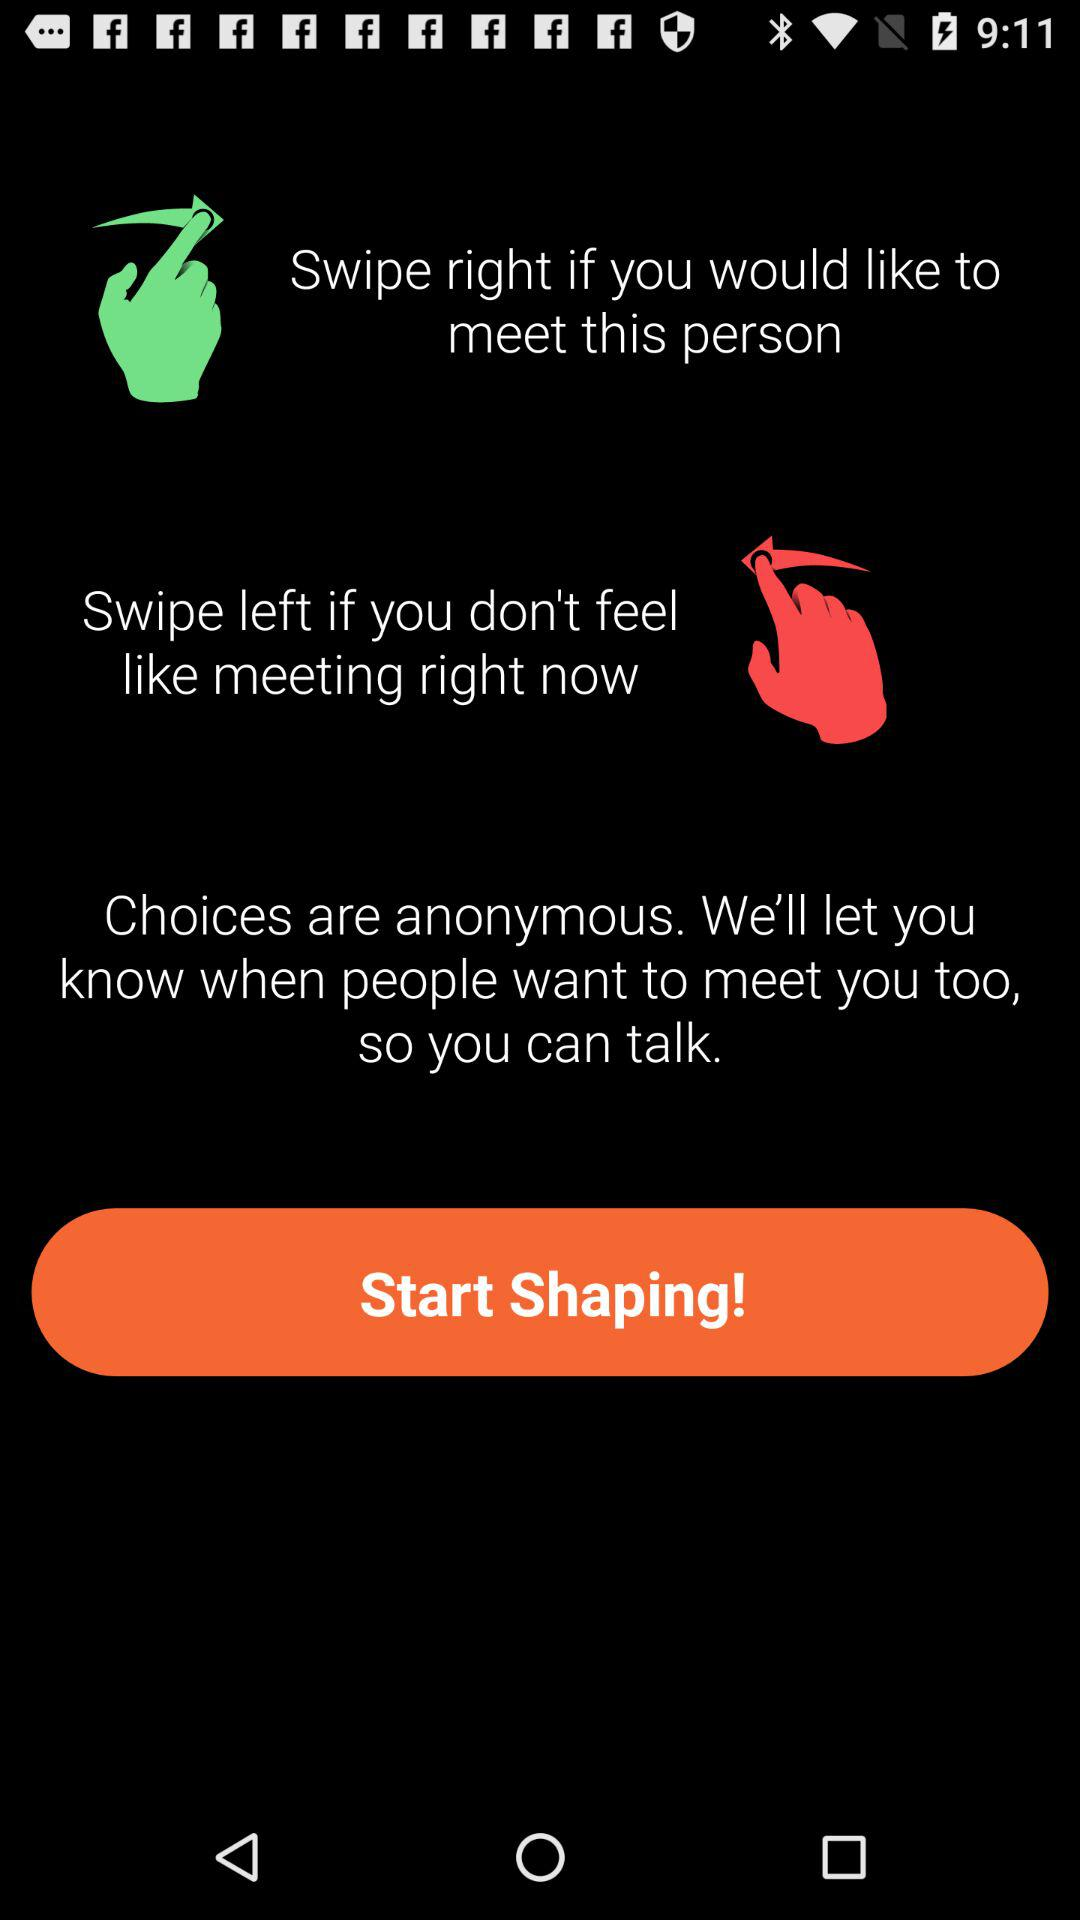How many swipe options are there?
Answer the question using a single word or phrase. 2 